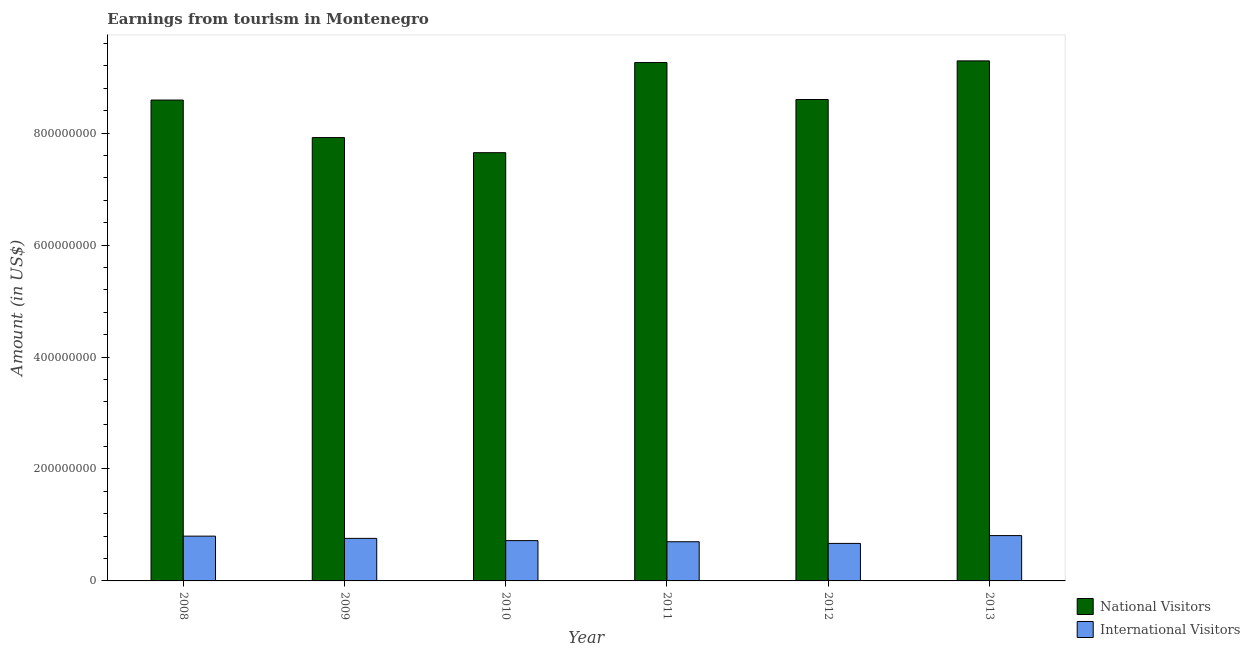How many different coloured bars are there?
Make the answer very short. 2. How many groups of bars are there?
Offer a very short reply. 6. Are the number of bars on each tick of the X-axis equal?
Give a very brief answer. Yes. What is the label of the 3rd group of bars from the left?
Provide a succinct answer. 2010. In how many cases, is the number of bars for a given year not equal to the number of legend labels?
Your response must be concise. 0. What is the amount earned from international visitors in 2013?
Ensure brevity in your answer.  8.10e+07. Across all years, what is the maximum amount earned from international visitors?
Keep it short and to the point. 8.10e+07. Across all years, what is the minimum amount earned from international visitors?
Your answer should be compact. 6.70e+07. In which year was the amount earned from international visitors maximum?
Your answer should be compact. 2013. What is the total amount earned from international visitors in the graph?
Offer a very short reply. 4.46e+08. What is the difference between the amount earned from national visitors in 2010 and that in 2011?
Your response must be concise. -1.61e+08. What is the difference between the amount earned from international visitors in 2013 and the amount earned from national visitors in 2009?
Offer a terse response. 5.00e+06. What is the average amount earned from national visitors per year?
Ensure brevity in your answer.  8.55e+08. What is the ratio of the amount earned from international visitors in 2008 to that in 2013?
Offer a terse response. 0.99. What is the difference between the highest and the second highest amount earned from international visitors?
Provide a succinct answer. 1.00e+06. What is the difference between the highest and the lowest amount earned from international visitors?
Keep it short and to the point. 1.40e+07. Is the sum of the amount earned from national visitors in 2012 and 2013 greater than the maximum amount earned from international visitors across all years?
Your answer should be compact. Yes. What does the 1st bar from the left in 2011 represents?
Your response must be concise. National Visitors. What does the 1st bar from the right in 2010 represents?
Make the answer very short. International Visitors. Are all the bars in the graph horizontal?
Your answer should be very brief. No. What is the difference between two consecutive major ticks on the Y-axis?
Give a very brief answer. 2.00e+08. Are the values on the major ticks of Y-axis written in scientific E-notation?
Provide a short and direct response. No. Does the graph contain grids?
Provide a short and direct response. No. How many legend labels are there?
Offer a very short reply. 2. How are the legend labels stacked?
Your answer should be compact. Vertical. What is the title of the graph?
Keep it short and to the point. Earnings from tourism in Montenegro. What is the label or title of the Y-axis?
Provide a succinct answer. Amount (in US$). What is the Amount (in US$) in National Visitors in 2008?
Make the answer very short. 8.59e+08. What is the Amount (in US$) of International Visitors in 2008?
Your answer should be very brief. 8.00e+07. What is the Amount (in US$) in National Visitors in 2009?
Provide a short and direct response. 7.92e+08. What is the Amount (in US$) of International Visitors in 2009?
Your answer should be compact. 7.60e+07. What is the Amount (in US$) in National Visitors in 2010?
Make the answer very short. 7.65e+08. What is the Amount (in US$) in International Visitors in 2010?
Provide a succinct answer. 7.20e+07. What is the Amount (in US$) of National Visitors in 2011?
Ensure brevity in your answer.  9.26e+08. What is the Amount (in US$) of International Visitors in 2011?
Keep it short and to the point. 7.00e+07. What is the Amount (in US$) in National Visitors in 2012?
Your response must be concise. 8.60e+08. What is the Amount (in US$) in International Visitors in 2012?
Give a very brief answer. 6.70e+07. What is the Amount (in US$) in National Visitors in 2013?
Provide a short and direct response. 9.29e+08. What is the Amount (in US$) of International Visitors in 2013?
Make the answer very short. 8.10e+07. Across all years, what is the maximum Amount (in US$) in National Visitors?
Provide a short and direct response. 9.29e+08. Across all years, what is the maximum Amount (in US$) in International Visitors?
Make the answer very short. 8.10e+07. Across all years, what is the minimum Amount (in US$) in National Visitors?
Provide a succinct answer. 7.65e+08. Across all years, what is the minimum Amount (in US$) in International Visitors?
Your response must be concise. 6.70e+07. What is the total Amount (in US$) in National Visitors in the graph?
Provide a short and direct response. 5.13e+09. What is the total Amount (in US$) of International Visitors in the graph?
Provide a succinct answer. 4.46e+08. What is the difference between the Amount (in US$) in National Visitors in 2008 and that in 2009?
Your response must be concise. 6.70e+07. What is the difference between the Amount (in US$) in National Visitors in 2008 and that in 2010?
Give a very brief answer. 9.40e+07. What is the difference between the Amount (in US$) of National Visitors in 2008 and that in 2011?
Give a very brief answer. -6.70e+07. What is the difference between the Amount (in US$) of International Visitors in 2008 and that in 2011?
Give a very brief answer. 1.00e+07. What is the difference between the Amount (in US$) of International Visitors in 2008 and that in 2012?
Ensure brevity in your answer.  1.30e+07. What is the difference between the Amount (in US$) in National Visitors in 2008 and that in 2013?
Your answer should be compact. -7.00e+07. What is the difference between the Amount (in US$) of National Visitors in 2009 and that in 2010?
Your answer should be compact. 2.70e+07. What is the difference between the Amount (in US$) of National Visitors in 2009 and that in 2011?
Your answer should be compact. -1.34e+08. What is the difference between the Amount (in US$) in International Visitors in 2009 and that in 2011?
Keep it short and to the point. 6.00e+06. What is the difference between the Amount (in US$) in National Visitors in 2009 and that in 2012?
Your answer should be very brief. -6.80e+07. What is the difference between the Amount (in US$) in International Visitors in 2009 and that in 2012?
Offer a very short reply. 9.00e+06. What is the difference between the Amount (in US$) in National Visitors in 2009 and that in 2013?
Give a very brief answer. -1.37e+08. What is the difference between the Amount (in US$) of International Visitors in 2009 and that in 2013?
Make the answer very short. -5.00e+06. What is the difference between the Amount (in US$) of National Visitors in 2010 and that in 2011?
Provide a succinct answer. -1.61e+08. What is the difference between the Amount (in US$) in National Visitors in 2010 and that in 2012?
Ensure brevity in your answer.  -9.50e+07. What is the difference between the Amount (in US$) of International Visitors in 2010 and that in 2012?
Your answer should be very brief. 5.00e+06. What is the difference between the Amount (in US$) of National Visitors in 2010 and that in 2013?
Make the answer very short. -1.64e+08. What is the difference between the Amount (in US$) of International Visitors in 2010 and that in 2013?
Your answer should be very brief. -9.00e+06. What is the difference between the Amount (in US$) in National Visitors in 2011 and that in 2012?
Your answer should be very brief. 6.60e+07. What is the difference between the Amount (in US$) of International Visitors in 2011 and that in 2012?
Provide a succinct answer. 3.00e+06. What is the difference between the Amount (in US$) in International Visitors in 2011 and that in 2013?
Your response must be concise. -1.10e+07. What is the difference between the Amount (in US$) in National Visitors in 2012 and that in 2013?
Your response must be concise. -6.90e+07. What is the difference between the Amount (in US$) in International Visitors in 2012 and that in 2013?
Ensure brevity in your answer.  -1.40e+07. What is the difference between the Amount (in US$) in National Visitors in 2008 and the Amount (in US$) in International Visitors in 2009?
Make the answer very short. 7.83e+08. What is the difference between the Amount (in US$) in National Visitors in 2008 and the Amount (in US$) in International Visitors in 2010?
Ensure brevity in your answer.  7.87e+08. What is the difference between the Amount (in US$) of National Visitors in 2008 and the Amount (in US$) of International Visitors in 2011?
Keep it short and to the point. 7.89e+08. What is the difference between the Amount (in US$) in National Visitors in 2008 and the Amount (in US$) in International Visitors in 2012?
Offer a terse response. 7.92e+08. What is the difference between the Amount (in US$) of National Visitors in 2008 and the Amount (in US$) of International Visitors in 2013?
Your response must be concise. 7.78e+08. What is the difference between the Amount (in US$) of National Visitors in 2009 and the Amount (in US$) of International Visitors in 2010?
Provide a short and direct response. 7.20e+08. What is the difference between the Amount (in US$) of National Visitors in 2009 and the Amount (in US$) of International Visitors in 2011?
Your response must be concise. 7.22e+08. What is the difference between the Amount (in US$) of National Visitors in 2009 and the Amount (in US$) of International Visitors in 2012?
Offer a terse response. 7.25e+08. What is the difference between the Amount (in US$) of National Visitors in 2009 and the Amount (in US$) of International Visitors in 2013?
Ensure brevity in your answer.  7.11e+08. What is the difference between the Amount (in US$) in National Visitors in 2010 and the Amount (in US$) in International Visitors in 2011?
Offer a terse response. 6.95e+08. What is the difference between the Amount (in US$) of National Visitors in 2010 and the Amount (in US$) of International Visitors in 2012?
Give a very brief answer. 6.98e+08. What is the difference between the Amount (in US$) of National Visitors in 2010 and the Amount (in US$) of International Visitors in 2013?
Give a very brief answer. 6.84e+08. What is the difference between the Amount (in US$) in National Visitors in 2011 and the Amount (in US$) in International Visitors in 2012?
Ensure brevity in your answer.  8.59e+08. What is the difference between the Amount (in US$) in National Visitors in 2011 and the Amount (in US$) in International Visitors in 2013?
Keep it short and to the point. 8.45e+08. What is the difference between the Amount (in US$) of National Visitors in 2012 and the Amount (in US$) of International Visitors in 2013?
Provide a short and direct response. 7.79e+08. What is the average Amount (in US$) in National Visitors per year?
Give a very brief answer. 8.55e+08. What is the average Amount (in US$) of International Visitors per year?
Ensure brevity in your answer.  7.43e+07. In the year 2008, what is the difference between the Amount (in US$) of National Visitors and Amount (in US$) of International Visitors?
Provide a short and direct response. 7.79e+08. In the year 2009, what is the difference between the Amount (in US$) of National Visitors and Amount (in US$) of International Visitors?
Keep it short and to the point. 7.16e+08. In the year 2010, what is the difference between the Amount (in US$) of National Visitors and Amount (in US$) of International Visitors?
Offer a terse response. 6.93e+08. In the year 2011, what is the difference between the Amount (in US$) of National Visitors and Amount (in US$) of International Visitors?
Offer a very short reply. 8.56e+08. In the year 2012, what is the difference between the Amount (in US$) of National Visitors and Amount (in US$) of International Visitors?
Provide a succinct answer. 7.93e+08. In the year 2013, what is the difference between the Amount (in US$) in National Visitors and Amount (in US$) in International Visitors?
Offer a very short reply. 8.48e+08. What is the ratio of the Amount (in US$) in National Visitors in 2008 to that in 2009?
Offer a very short reply. 1.08. What is the ratio of the Amount (in US$) of International Visitors in 2008 to that in 2009?
Your answer should be very brief. 1.05. What is the ratio of the Amount (in US$) of National Visitors in 2008 to that in 2010?
Offer a very short reply. 1.12. What is the ratio of the Amount (in US$) in International Visitors in 2008 to that in 2010?
Offer a very short reply. 1.11. What is the ratio of the Amount (in US$) in National Visitors in 2008 to that in 2011?
Offer a very short reply. 0.93. What is the ratio of the Amount (in US$) of International Visitors in 2008 to that in 2011?
Offer a terse response. 1.14. What is the ratio of the Amount (in US$) of National Visitors in 2008 to that in 2012?
Give a very brief answer. 1. What is the ratio of the Amount (in US$) of International Visitors in 2008 to that in 2012?
Offer a very short reply. 1.19. What is the ratio of the Amount (in US$) of National Visitors in 2008 to that in 2013?
Offer a terse response. 0.92. What is the ratio of the Amount (in US$) in International Visitors in 2008 to that in 2013?
Provide a succinct answer. 0.99. What is the ratio of the Amount (in US$) of National Visitors in 2009 to that in 2010?
Offer a very short reply. 1.04. What is the ratio of the Amount (in US$) in International Visitors in 2009 to that in 2010?
Your answer should be compact. 1.06. What is the ratio of the Amount (in US$) in National Visitors in 2009 to that in 2011?
Give a very brief answer. 0.86. What is the ratio of the Amount (in US$) in International Visitors in 2009 to that in 2011?
Offer a very short reply. 1.09. What is the ratio of the Amount (in US$) in National Visitors in 2009 to that in 2012?
Your response must be concise. 0.92. What is the ratio of the Amount (in US$) in International Visitors in 2009 to that in 2012?
Your answer should be very brief. 1.13. What is the ratio of the Amount (in US$) in National Visitors in 2009 to that in 2013?
Offer a very short reply. 0.85. What is the ratio of the Amount (in US$) of International Visitors in 2009 to that in 2013?
Provide a succinct answer. 0.94. What is the ratio of the Amount (in US$) in National Visitors in 2010 to that in 2011?
Provide a succinct answer. 0.83. What is the ratio of the Amount (in US$) in International Visitors in 2010 to that in 2011?
Ensure brevity in your answer.  1.03. What is the ratio of the Amount (in US$) of National Visitors in 2010 to that in 2012?
Your answer should be compact. 0.89. What is the ratio of the Amount (in US$) of International Visitors in 2010 to that in 2012?
Offer a very short reply. 1.07. What is the ratio of the Amount (in US$) of National Visitors in 2010 to that in 2013?
Offer a terse response. 0.82. What is the ratio of the Amount (in US$) in International Visitors in 2010 to that in 2013?
Provide a succinct answer. 0.89. What is the ratio of the Amount (in US$) in National Visitors in 2011 to that in 2012?
Your response must be concise. 1.08. What is the ratio of the Amount (in US$) of International Visitors in 2011 to that in 2012?
Provide a succinct answer. 1.04. What is the ratio of the Amount (in US$) in National Visitors in 2011 to that in 2013?
Keep it short and to the point. 1. What is the ratio of the Amount (in US$) in International Visitors in 2011 to that in 2013?
Your answer should be very brief. 0.86. What is the ratio of the Amount (in US$) of National Visitors in 2012 to that in 2013?
Your answer should be compact. 0.93. What is the ratio of the Amount (in US$) of International Visitors in 2012 to that in 2013?
Your answer should be very brief. 0.83. What is the difference between the highest and the second highest Amount (in US$) in National Visitors?
Offer a terse response. 3.00e+06. What is the difference between the highest and the lowest Amount (in US$) of National Visitors?
Your response must be concise. 1.64e+08. What is the difference between the highest and the lowest Amount (in US$) in International Visitors?
Make the answer very short. 1.40e+07. 